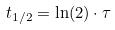<formula> <loc_0><loc_0><loc_500><loc_500>t _ { 1 / 2 } = \ln ( 2 ) \cdot \tau</formula> 